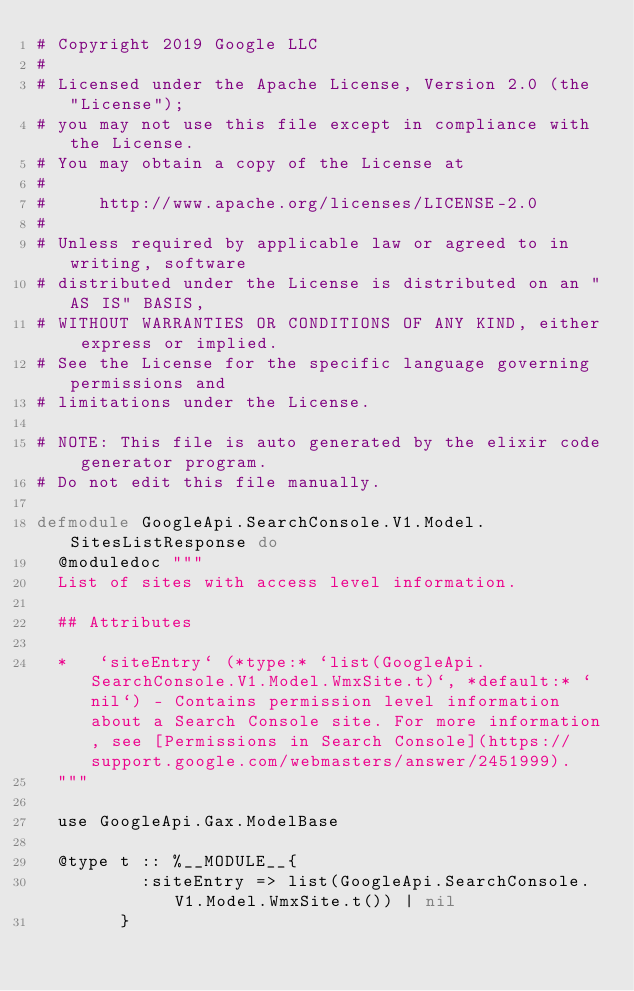<code> <loc_0><loc_0><loc_500><loc_500><_Elixir_># Copyright 2019 Google LLC
#
# Licensed under the Apache License, Version 2.0 (the "License");
# you may not use this file except in compliance with the License.
# You may obtain a copy of the License at
#
#     http://www.apache.org/licenses/LICENSE-2.0
#
# Unless required by applicable law or agreed to in writing, software
# distributed under the License is distributed on an "AS IS" BASIS,
# WITHOUT WARRANTIES OR CONDITIONS OF ANY KIND, either express or implied.
# See the License for the specific language governing permissions and
# limitations under the License.

# NOTE: This file is auto generated by the elixir code generator program.
# Do not edit this file manually.

defmodule GoogleApi.SearchConsole.V1.Model.SitesListResponse do
  @moduledoc """
  List of sites with access level information.

  ## Attributes

  *   `siteEntry` (*type:* `list(GoogleApi.SearchConsole.V1.Model.WmxSite.t)`, *default:* `nil`) - Contains permission level information about a Search Console site. For more information, see [Permissions in Search Console](https://support.google.com/webmasters/answer/2451999).
  """

  use GoogleApi.Gax.ModelBase

  @type t :: %__MODULE__{
          :siteEntry => list(GoogleApi.SearchConsole.V1.Model.WmxSite.t()) | nil
        }
</code> 